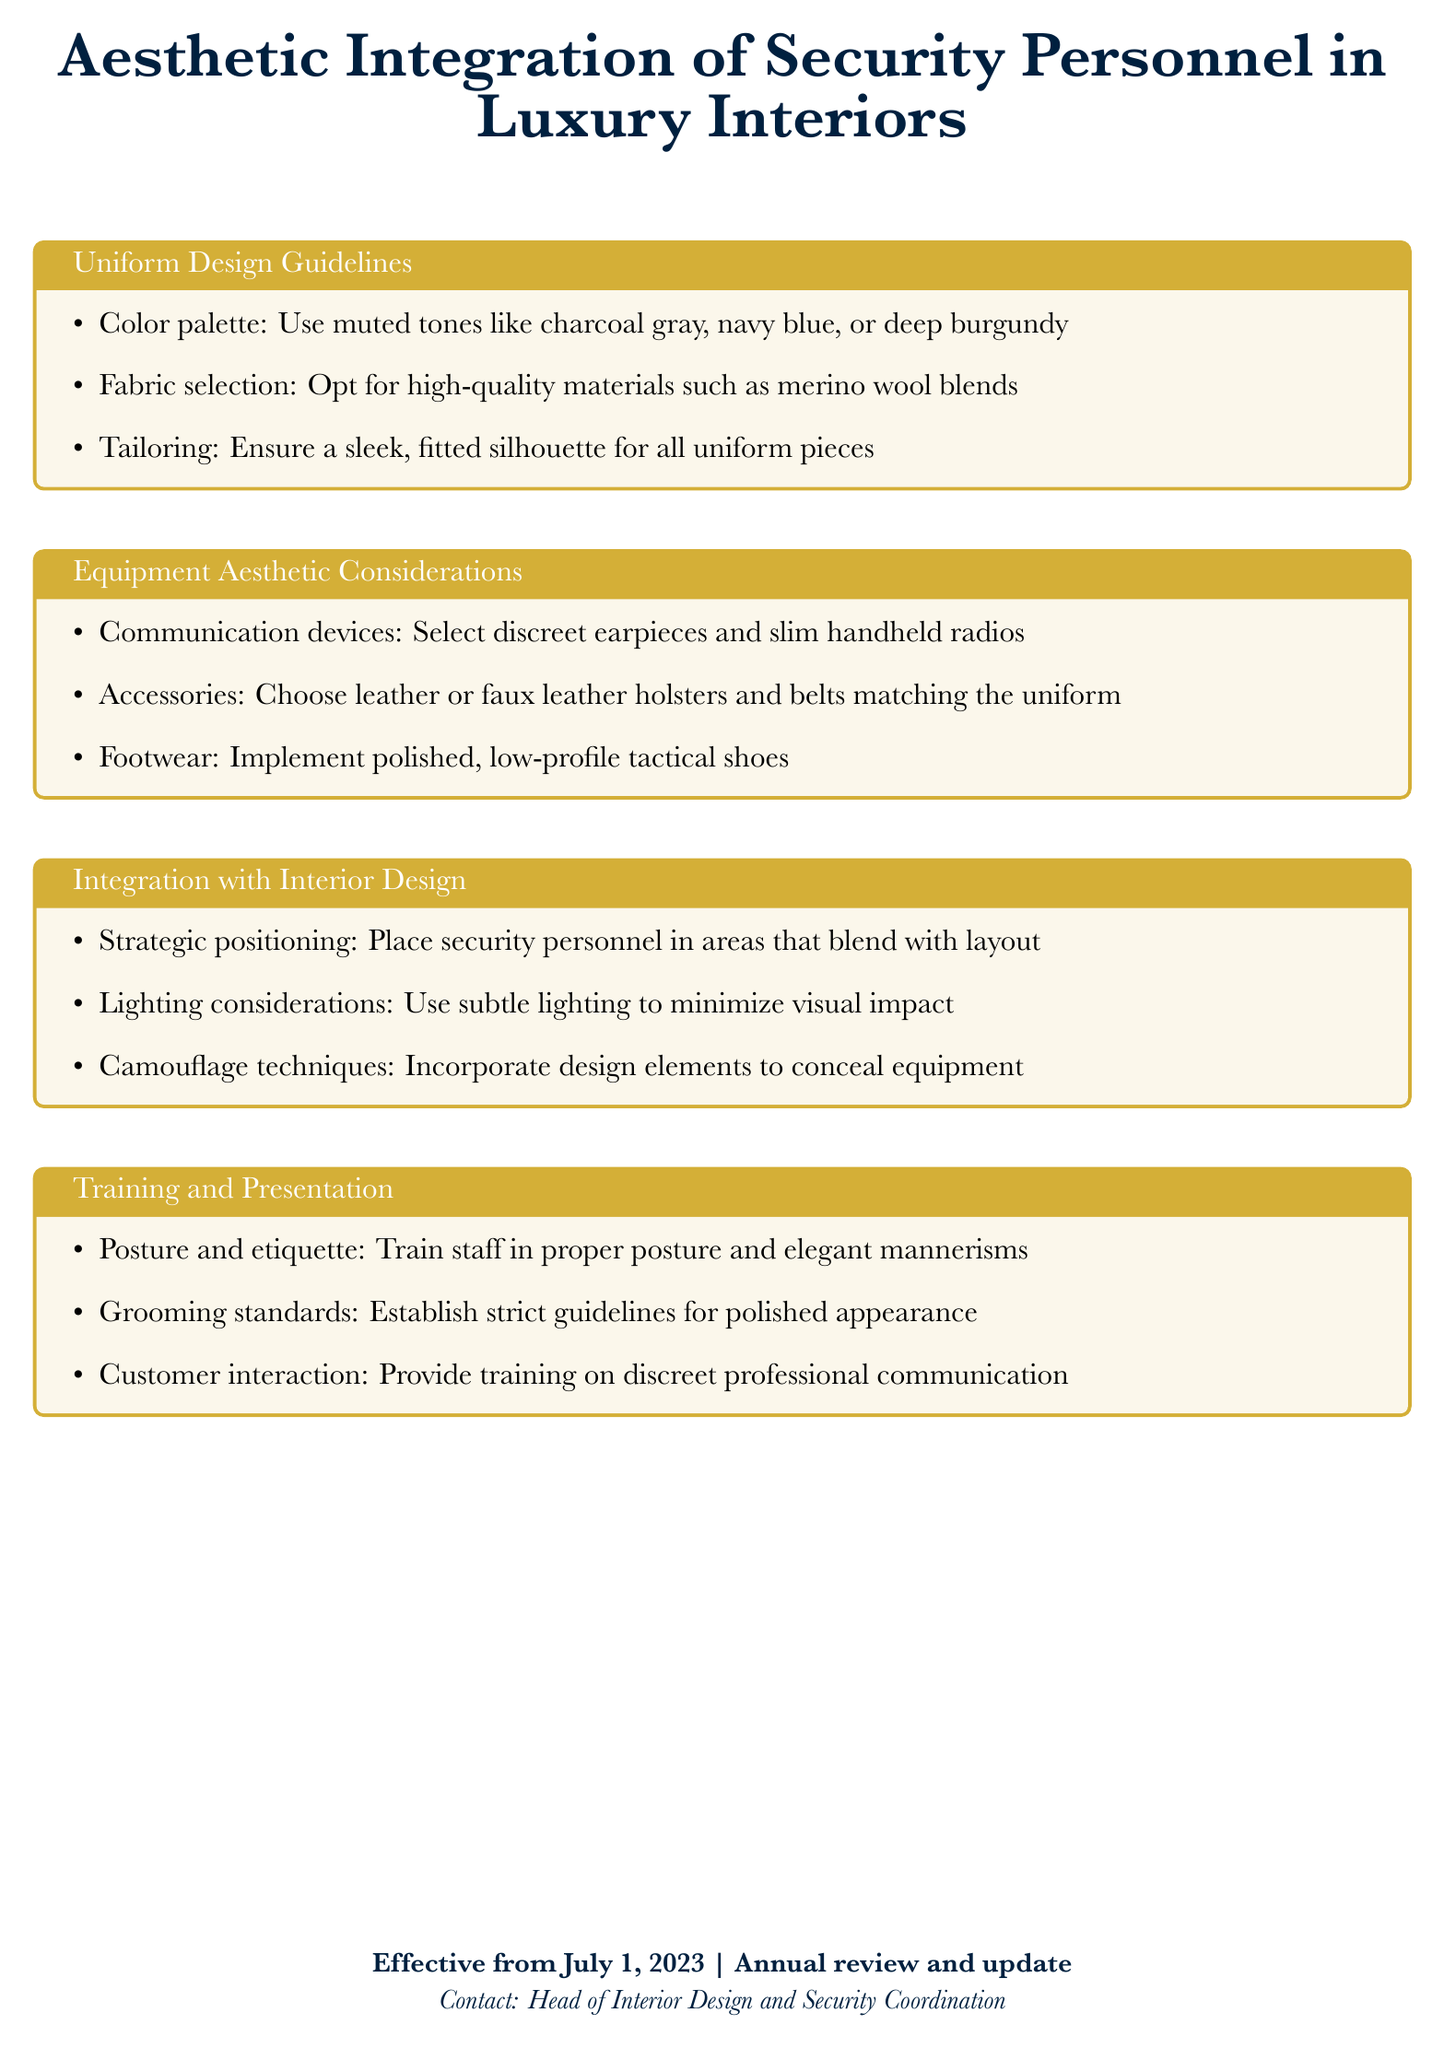What are the recommended colors for uniforms? The document specifies muted tones like charcoal gray, navy blue, or deep burgundy for uniform colors.
Answer: charcoal gray, navy blue, deep burgundy What fabric is suggested for uniform selection? The document recommends high-quality materials such as merino wool blends for uniforms.
Answer: merino wool blends What type of shoes should be implemented for security personnel? The document advises using polished, low-profile tactical shoes for footwear.
Answer: polished, low-profile tactical shoes What is the effective date of the policy? The policy states it is effective from July 1, 2023, and mentions annual review and update.
Answer: July 1, 2023 What are the training standards mentioned for staff appearance? The document indicates the establishment of strict guidelines for polished appearance as part of grooming standards.
Answer: polished appearance What should the positioning of security personnel consider? The document emphasizes strategic positioning of security personnel to blend with the layout.
Answer: strategic positioning What lighting technique is recommended to minimize visual impact? The document suggests subtle lighting as a technique to minimize visual impact.
Answer: subtle lighting What type of communication devices should security staff use? The guidelines recommend selecting discreet earpieces and slim handheld radios for communication devices.
Answer: discreet earpieces, slim handheld radios 